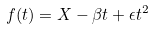<formula> <loc_0><loc_0><loc_500><loc_500>f ( t ) = X - \beta t + \epsilon t ^ { 2 }</formula> 